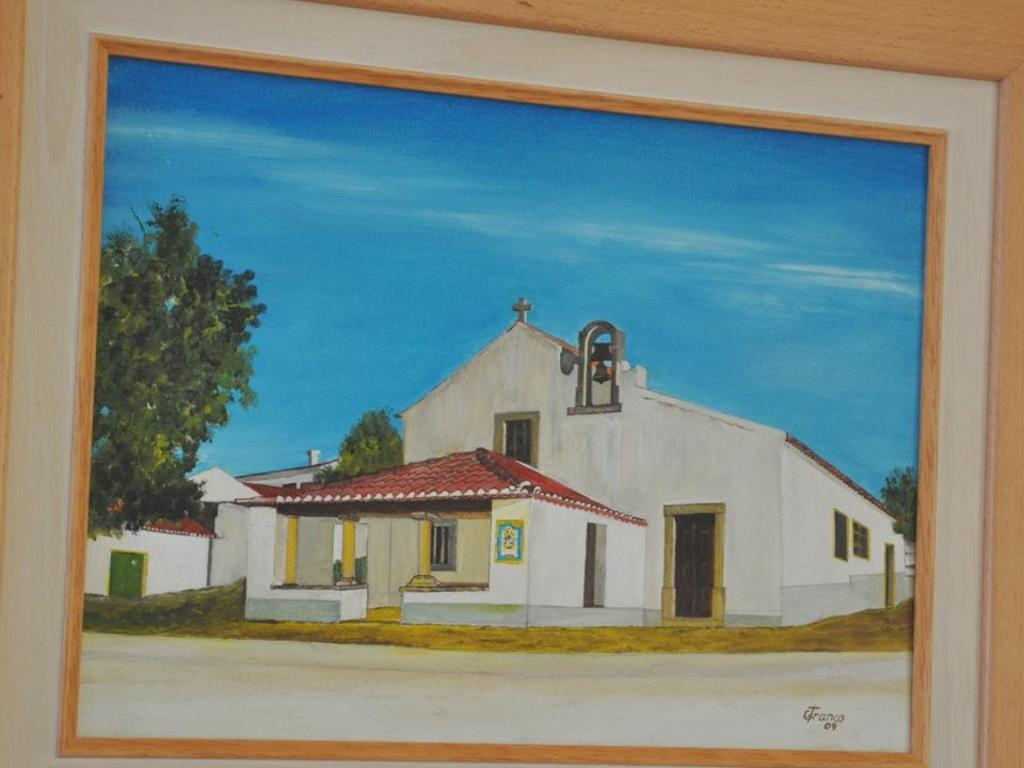What object is present in the image that typically holds a picture or image? There is a photo frame in the image. What is depicted within the photo frame? The photo frame contains a drawing of a church. What additional elements are included in the drawing? The drawing includes houses. What type of natural vegetation can be seen in the image? There are trees visible in the image. What part of the natural environment is visible at the top of the image? The sky is visible at the top of the image. What type of drink is being served in the image? There is no drink present in the image; it features a photo frame with a drawing of a church. How many lizards can be seen in the image? There are no lizards present in the image. 